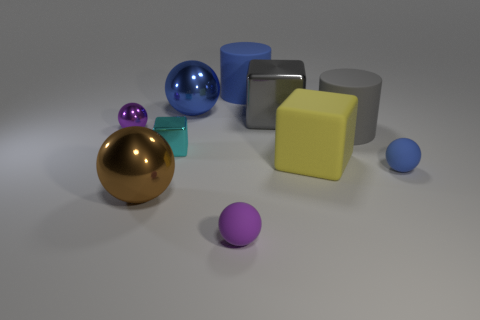There is a large gray thing that is the same shape as the small cyan metal thing; what is its material?
Provide a short and direct response. Metal. Is the gray matte object the same shape as the large yellow object?
Provide a succinct answer. No. There is a tiny cyan block; how many large spheres are on the left side of it?
Your answer should be very brief. 1. What shape is the blue thing to the right of the object that is behind the blue metal ball?
Keep it short and to the point. Sphere. What shape is the purple object that is the same material as the large yellow object?
Offer a terse response. Sphere. Is the size of the metallic object in front of the small blue rubber sphere the same as the blue rubber thing behind the small metallic block?
Your response must be concise. Yes. What shape is the shiny thing that is in front of the blue matte sphere?
Ensure brevity in your answer.  Sphere. The small cube has what color?
Your response must be concise. Cyan. Is the size of the blue rubber sphere the same as the rubber cylinder behind the gray rubber cylinder?
Give a very brief answer. No. How many shiny things are blue cylinders or large yellow balls?
Give a very brief answer. 0. 